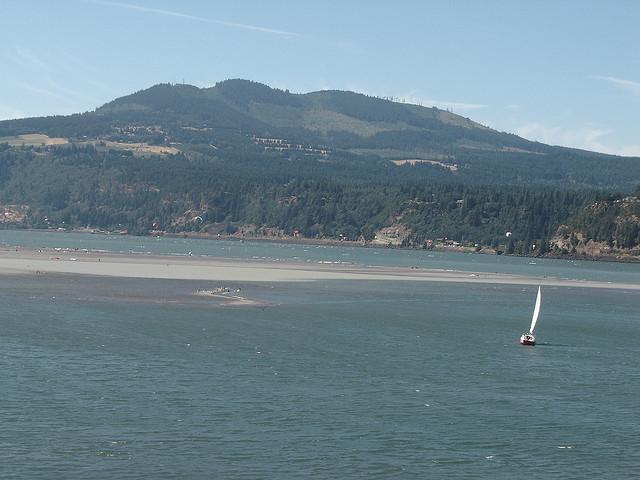Is there a person in the water?
Answer briefly. No. What type of boat is on the water?
Write a very short answer. Sailboat. Are any of the sailboats using their sails?
Give a very brief answer. Yes. How deep is the water?
Concise answer only. Deep. What landforms are in the background?
Give a very brief answer. Mountains. How many people are parasailing?
Write a very short answer. 1. Does this photograph have a vignette (darkened corners)?
Be succinct. No. What type of boat is this?
Concise answer only. Sailboat. How many boats can be seen?
Be succinct. 1. How deep would the water be?
Be succinct. Deep. What type of water body is this?
Keep it brief. Lake. Is this boat stuck in mud?
Concise answer only. No. 